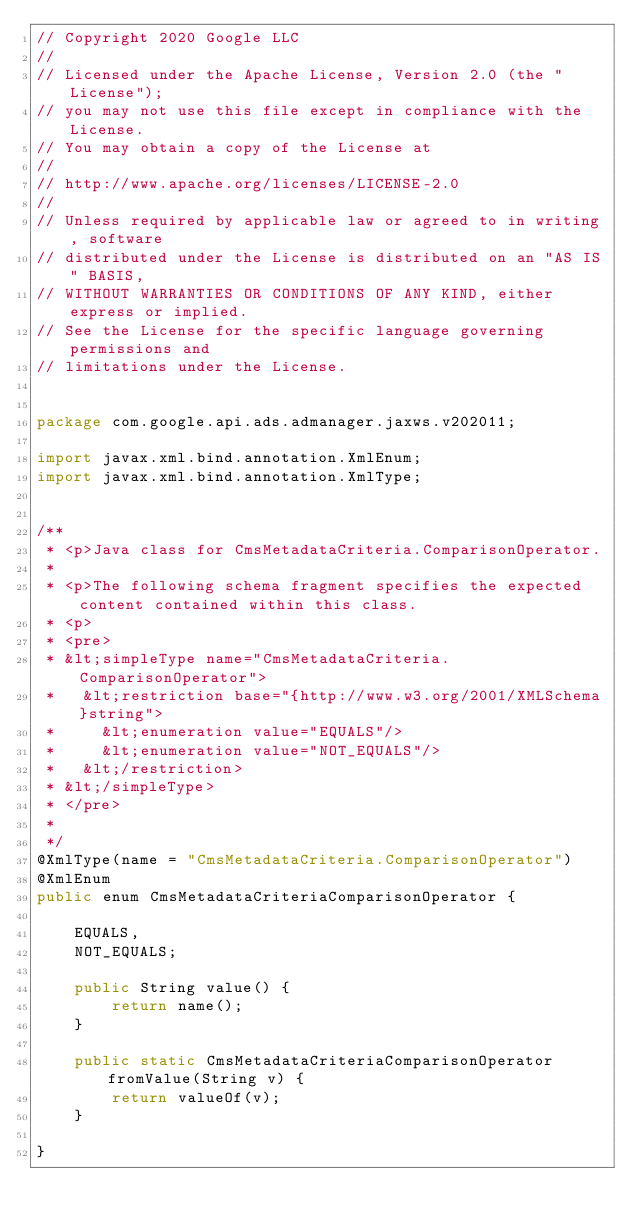Convert code to text. <code><loc_0><loc_0><loc_500><loc_500><_Java_>// Copyright 2020 Google LLC
//
// Licensed under the Apache License, Version 2.0 (the "License");
// you may not use this file except in compliance with the License.
// You may obtain a copy of the License at
//
// http://www.apache.org/licenses/LICENSE-2.0
//
// Unless required by applicable law or agreed to in writing, software
// distributed under the License is distributed on an "AS IS" BASIS,
// WITHOUT WARRANTIES OR CONDITIONS OF ANY KIND, either express or implied.
// See the License for the specific language governing permissions and
// limitations under the License.


package com.google.api.ads.admanager.jaxws.v202011;

import javax.xml.bind.annotation.XmlEnum;
import javax.xml.bind.annotation.XmlType;


/**
 * <p>Java class for CmsMetadataCriteria.ComparisonOperator.
 * 
 * <p>The following schema fragment specifies the expected content contained within this class.
 * <p>
 * <pre>
 * &lt;simpleType name="CmsMetadataCriteria.ComparisonOperator">
 *   &lt;restriction base="{http://www.w3.org/2001/XMLSchema}string">
 *     &lt;enumeration value="EQUALS"/>
 *     &lt;enumeration value="NOT_EQUALS"/>
 *   &lt;/restriction>
 * &lt;/simpleType>
 * </pre>
 * 
 */
@XmlType(name = "CmsMetadataCriteria.ComparisonOperator")
@XmlEnum
public enum CmsMetadataCriteriaComparisonOperator {

    EQUALS,
    NOT_EQUALS;

    public String value() {
        return name();
    }

    public static CmsMetadataCriteriaComparisonOperator fromValue(String v) {
        return valueOf(v);
    }

}
</code> 